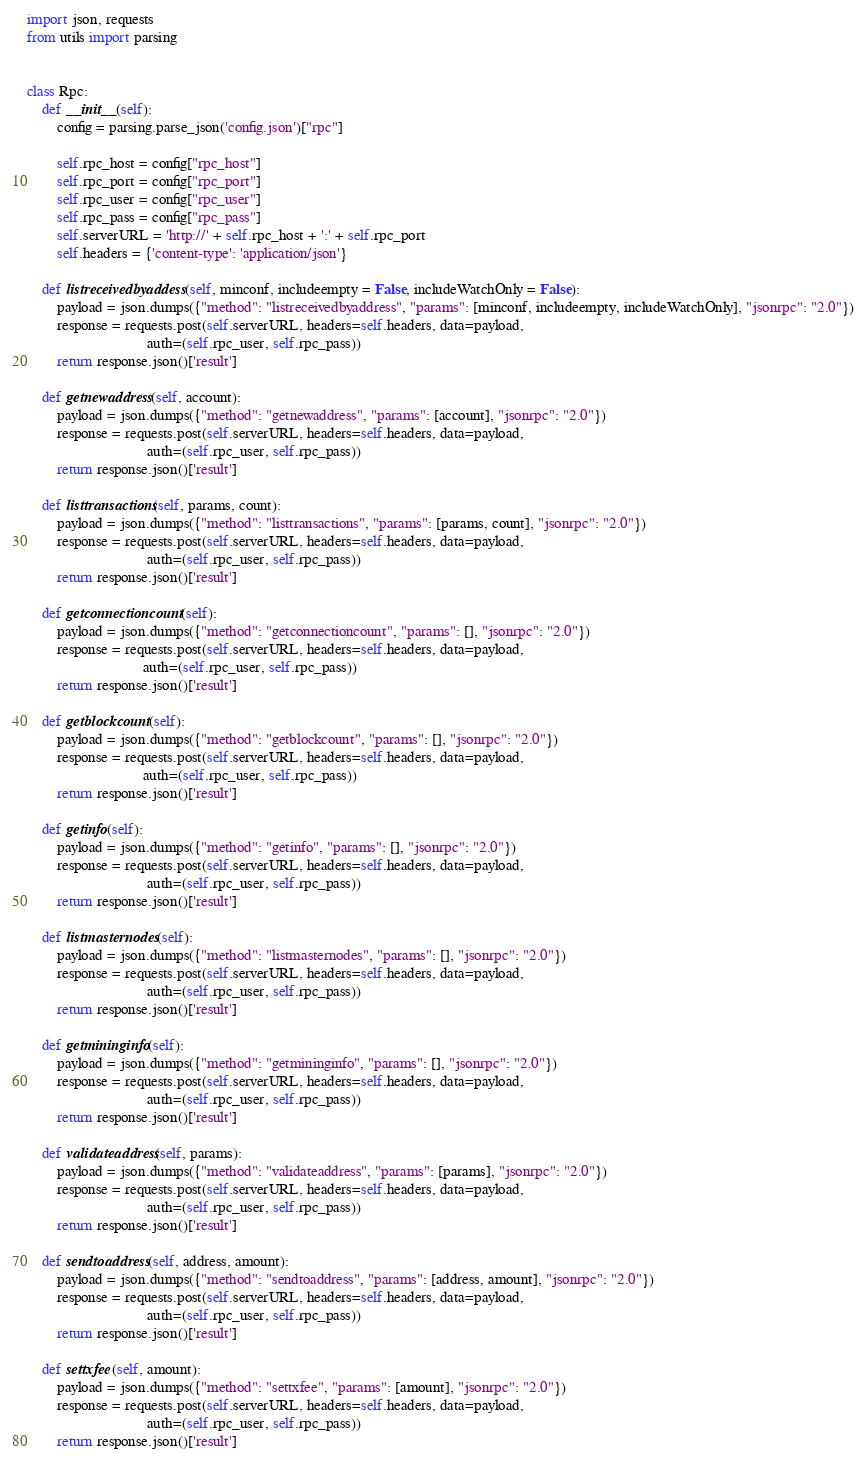Convert code to text. <code><loc_0><loc_0><loc_500><loc_500><_Python_>import json, requests
from utils import parsing


class Rpc:
    def __init__(self):
        config = parsing.parse_json('config.json')["rpc"]

        self.rpc_host = config["rpc_host"]
        self.rpc_port = config["rpc_port"]
        self.rpc_user = config["rpc_user"]
        self.rpc_pass = config["rpc_pass"]
        self.serverURL = 'http://' + self.rpc_host + ':' + self.rpc_port
        self.headers = {'content-type': 'application/json'}

    def listreceivedbyaddess(self, minconf, includeempty = False, includeWatchOnly = False):
        payload = json.dumps({"method": "listreceivedbyaddress", "params": [minconf, includeempty, includeWatchOnly], "jsonrpc": "2.0"})
        response = requests.post(self.serverURL, headers=self.headers, data=payload,
                                auth=(self.rpc_user, self.rpc_pass))
        return response.json()['result']

    def getnewaddress(self, account):
        payload = json.dumps({"method": "getnewaddress", "params": [account], "jsonrpc": "2.0"})
        response = requests.post(self.serverURL, headers=self.headers, data=payload,
                                auth=(self.rpc_user, self.rpc_pass))
        return response.json()['result']

    def listtransactions(self, params, count):
        payload = json.dumps({"method": "listtransactions", "params": [params, count], "jsonrpc": "2.0"})
        response = requests.post(self.serverURL, headers=self.headers, data=payload,
                                auth=(self.rpc_user, self.rpc_pass))
        return response.json()['result']
    
    def getconnectioncount(self):
        payload = json.dumps({"method": "getconnectioncount", "params": [], "jsonrpc": "2.0"})
        response = requests.post(self.serverURL, headers=self.headers, data=payload,
                               auth=(self.rpc_user, self.rpc_pass))
        return response.json()['result']

    def getblockcount(self):
        payload = json.dumps({"method": "getblockcount", "params": [], "jsonrpc": "2.0"})
        response = requests.post(self.serverURL, headers=self.headers, data=payload,
                               auth=(self.rpc_user, self.rpc_pass))
        return response.json()['result']

    def getinfo(self):
        payload = json.dumps({"method": "getinfo", "params": [], "jsonrpc": "2.0"})
        response = requests.post(self.serverURL, headers=self.headers, data=payload,
                                auth=(self.rpc_user, self.rpc_pass))
        return response.json()['result']

    def listmasternodes(self):
        payload = json.dumps({"method": "listmasternodes", "params": [], "jsonrpc": "2.0"})
        response = requests.post(self.serverURL, headers=self.headers, data=payload,
                                auth=(self.rpc_user, self.rpc_pass))
        return response.json()['result']

    def getmininginfo(self):
        payload = json.dumps({"method": "getmininginfo", "params": [], "jsonrpc": "2.0"})
        response = requests.post(self.serverURL, headers=self.headers, data=payload,
                                auth=(self.rpc_user, self.rpc_pass))
        return response.json()['result']

    def validateaddress(self, params):
        payload = json.dumps({"method": "validateaddress", "params": [params], "jsonrpc": "2.0"})
        response = requests.post(self.serverURL, headers=self.headers, data=payload,
                                auth=(self.rpc_user, self.rpc_pass))
        return response.json()['result']

    def sendtoaddress(self, address, amount):
        payload = json.dumps({"method": "sendtoaddress", "params": [address, amount], "jsonrpc": "2.0"})
        response = requests.post(self.serverURL, headers=self.headers, data=payload,
                                auth=(self.rpc_user, self.rpc_pass))
        return response.json()['result']

    def settxfee(self, amount):
        payload = json.dumps({"method": "settxfee", "params": [amount], "jsonrpc": "2.0"})
        response = requests.post(self.serverURL, headers=self.headers, data=payload,
                                auth=(self.rpc_user, self.rpc_pass))
        return response.json()['result']
</code> 